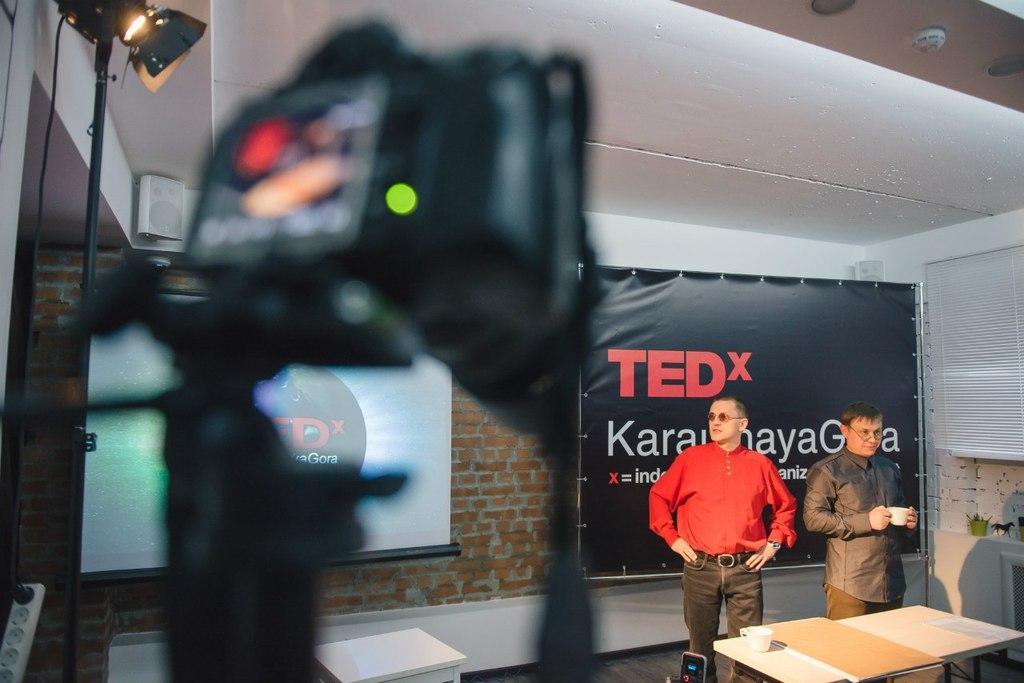Could you give a brief overview of what you see in this image? As we can see in the image there is a brick wall, screen, lights, banner and two people standing over here. In front of them there is a table. On table there is a book and cup. 